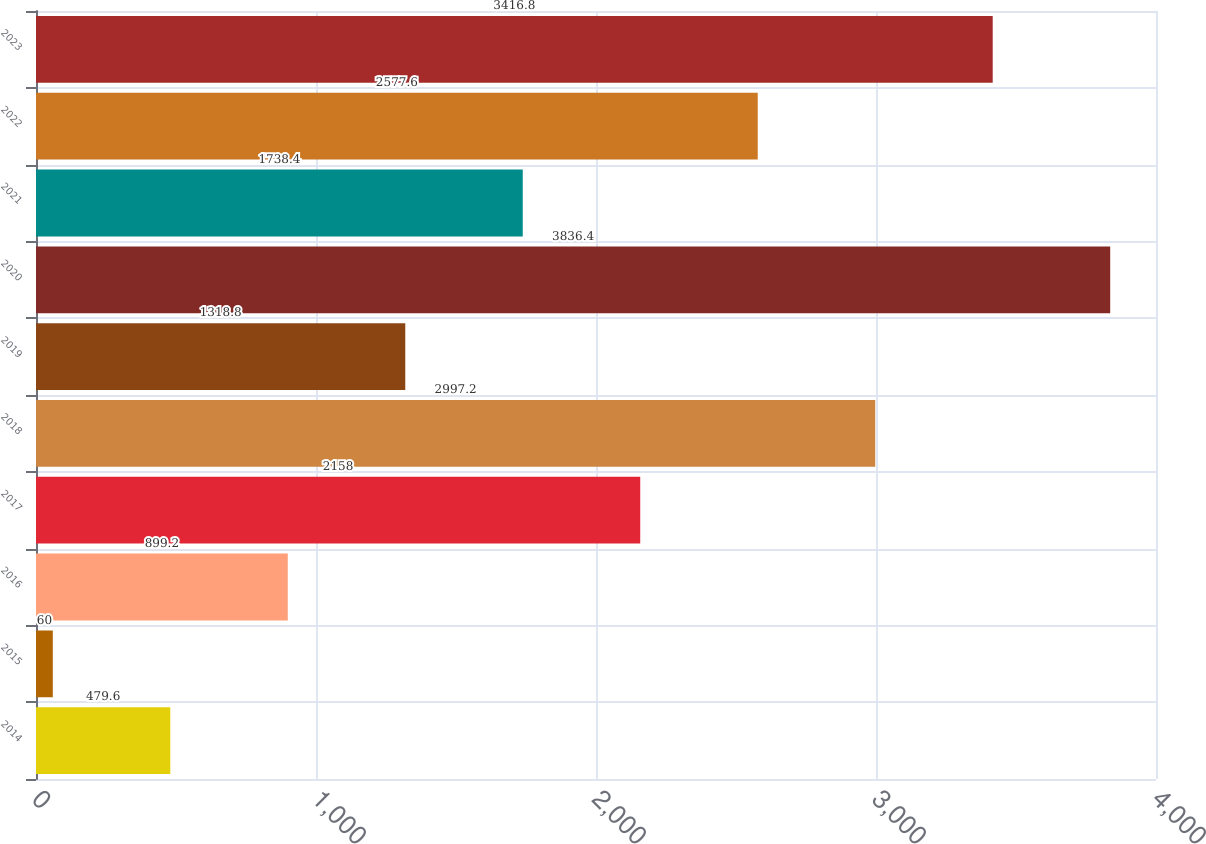Convert chart. <chart><loc_0><loc_0><loc_500><loc_500><bar_chart><fcel>2014<fcel>2015<fcel>2016<fcel>2017<fcel>2018<fcel>2019<fcel>2020<fcel>2021<fcel>2022<fcel>2023<nl><fcel>479.6<fcel>60<fcel>899.2<fcel>2158<fcel>2997.2<fcel>1318.8<fcel>3836.4<fcel>1738.4<fcel>2577.6<fcel>3416.8<nl></chart> 